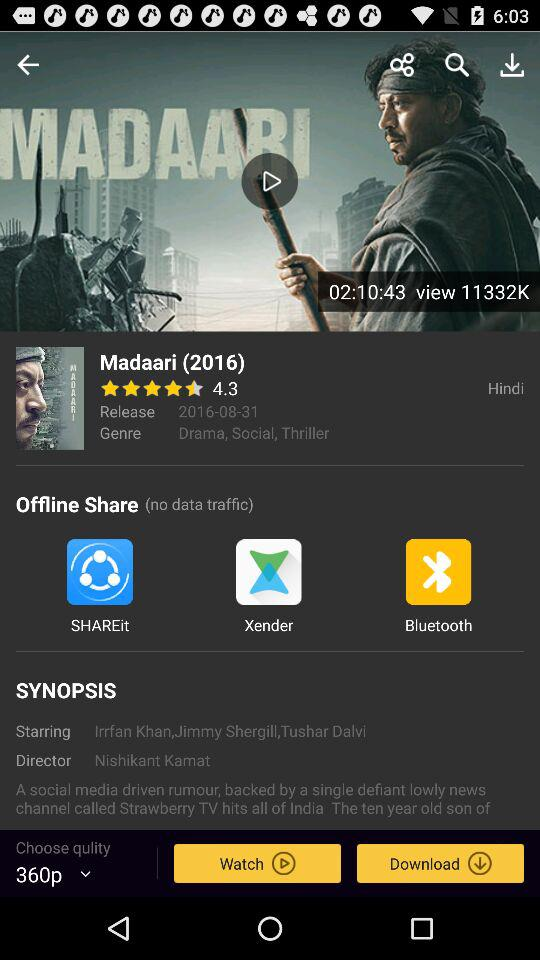What is the rating of the movie?
Answer the question using a single word or phrase. 4.3 